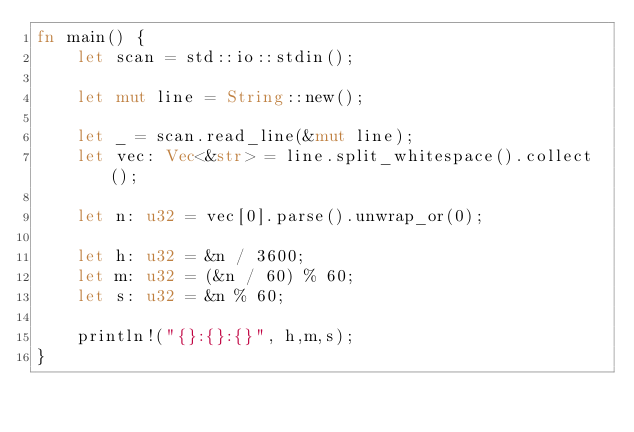Convert code to text. <code><loc_0><loc_0><loc_500><loc_500><_Rust_>fn main() {
    let scan = std::io::stdin();

    let mut line = String::new();

    let _ = scan.read_line(&mut line);
    let vec: Vec<&str> = line.split_whitespace().collect();

    let n: u32 = vec[0].parse().unwrap_or(0);

    let h: u32 = &n / 3600;
    let m: u32 = (&n / 60) % 60;
    let s: u32 = &n % 60;

    println!("{}:{}:{}", h,m,s);
}
</code> 